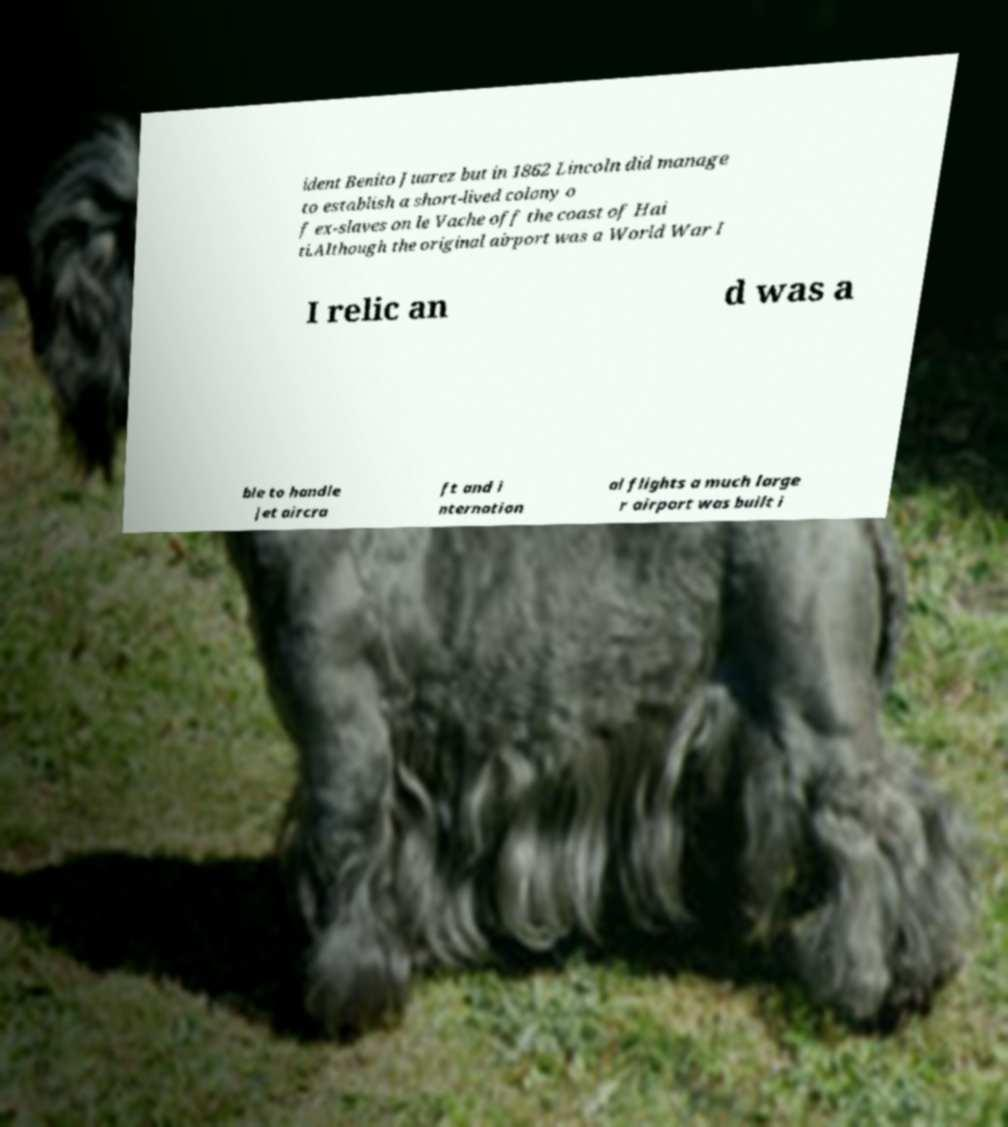Please read and relay the text visible in this image. What does it say? ident Benito Juarez but in 1862 Lincoln did manage to establish a short-lived colony o f ex-slaves on le Vache off the coast of Hai ti.Although the original airport was a World War I I relic an d was a ble to handle jet aircra ft and i nternation al flights a much large r airport was built i 